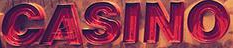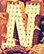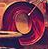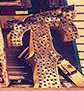Transcribe the words shown in these images in order, separated by a semicolon. CASINO; N; O; T 